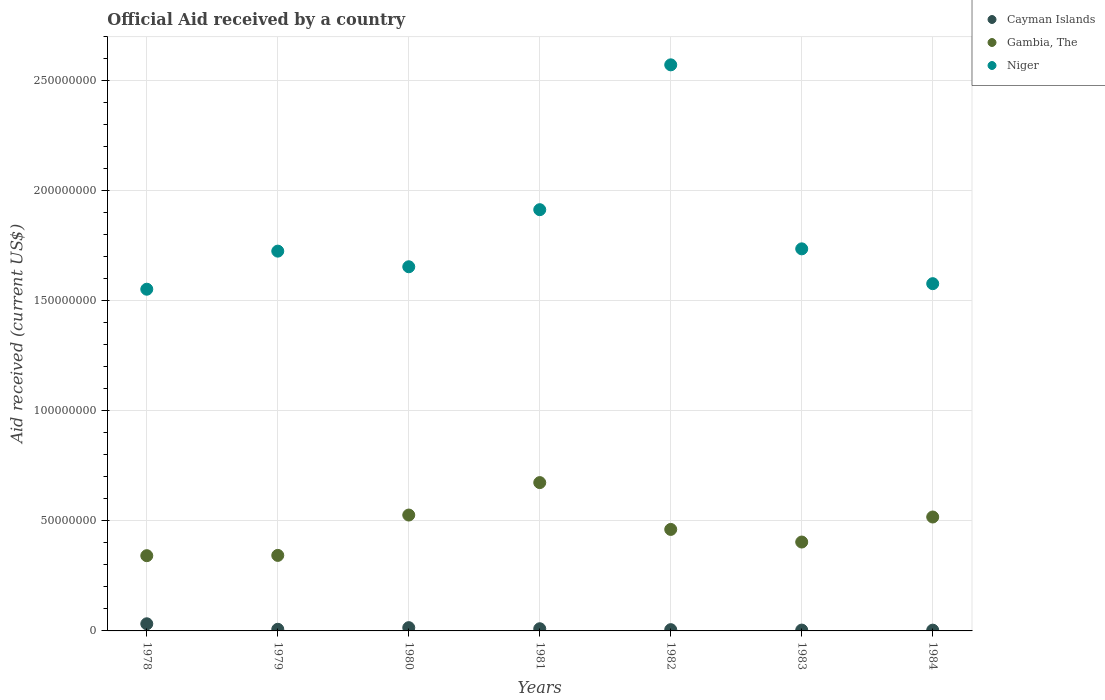How many different coloured dotlines are there?
Your answer should be very brief. 3. What is the net official aid received in Gambia, The in 1983?
Your response must be concise. 4.04e+07. Across all years, what is the maximum net official aid received in Cayman Islands?
Ensure brevity in your answer.  3.24e+06. In which year was the net official aid received in Niger maximum?
Your answer should be very brief. 1982. What is the total net official aid received in Niger in the graph?
Offer a terse response. 1.27e+09. What is the difference between the net official aid received in Niger in 1980 and that in 1981?
Provide a short and direct response. -2.59e+07. What is the difference between the net official aid received in Cayman Islands in 1984 and the net official aid received in Gambia, The in 1982?
Your answer should be compact. -4.58e+07. What is the average net official aid received in Cayman Islands per year?
Give a very brief answer. 1.11e+06. In the year 1978, what is the difference between the net official aid received in Niger and net official aid received in Cayman Islands?
Provide a succinct answer. 1.52e+08. In how many years, is the net official aid received in Gambia, The greater than 220000000 US$?
Offer a very short reply. 0. What is the ratio of the net official aid received in Cayman Islands in 1979 to that in 1982?
Offer a terse response. 1.3. Is the net official aid received in Gambia, The in 1979 less than that in 1980?
Your answer should be compact. Yes. Is the difference between the net official aid received in Niger in 1983 and 1984 greater than the difference between the net official aid received in Cayman Islands in 1983 and 1984?
Your answer should be very brief. Yes. What is the difference between the highest and the second highest net official aid received in Cayman Islands?
Provide a succinct answer. 1.75e+06. What is the difference between the highest and the lowest net official aid received in Niger?
Your answer should be very brief. 1.02e+08. In how many years, is the net official aid received in Niger greater than the average net official aid received in Niger taken over all years?
Offer a terse response. 2. Is the sum of the net official aid received in Gambia, The in 1979 and 1984 greater than the maximum net official aid received in Niger across all years?
Provide a succinct answer. No. Does the net official aid received in Niger monotonically increase over the years?
Ensure brevity in your answer.  No. Is the net official aid received in Niger strictly greater than the net official aid received in Cayman Islands over the years?
Ensure brevity in your answer.  Yes. What is the difference between two consecutive major ticks on the Y-axis?
Offer a terse response. 5.00e+07. Are the values on the major ticks of Y-axis written in scientific E-notation?
Keep it short and to the point. No. Where does the legend appear in the graph?
Offer a very short reply. Top right. What is the title of the graph?
Keep it short and to the point. Official Aid received by a country. Does "Cuba" appear as one of the legend labels in the graph?
Offer a terse response. No. What is the label or title of the X-axis?
Ensure brevity in your answer.  Years. What is the label or title of the Y-axis?
Provide a short and direct response. Aid received (current US$). What is the Aid received (current US$) in Cayman Islands in 1978?
Your response must be concise. 3.24e+06. What is the Aid received (current US$) of Gambia, The in 1978?
Provide a succinct answer. 3.42e+07. What is the Aid received (current US$) in Niger in 1978?
Make the answer very short. 1.55e+08. What is the Aid received (current US$) of Cayman Islands in 1979?
Your answer should be very brief. 7.40e+05. What is the Aid received (current US$) of Gambia, The in 1979?
Provide a succinct answer. 3.43e+07. What is the Aid received (current US$) in Niger in 1979?
Ensure brevity in your answer.  1.73e+08. What is the Aid received (current US$) of Cayman Islands in 1980?
Ensure brevity in your answer.  1.49e+06. What is the Aid received (current US$) in Gambia, The in 1980?
Ensure brevity in your answer.  5.26e+07. What is the Aid received (current US$) of Niger in 1980?
Offer a terse response. 1.65e+08. What is the Aid received (current US$) in Cayman Islands in 1981?
Your answer should be compact. 9.90e+05. What is the Aid received (current US$) of Gambia, The in 1981?
Give a very brief answer. 6.74e+07. What is the Aid received (current US$) in Niger in 1981?
Ensure brevity in your answer.  1.91e+08. What is the Aid received (current US$) in Cayman Islands in 1982?
Offer a very short reply. 5.70e+05. What is the Aid received (current US$) in Gambia, The in 1982?
Make the answer very short. 4.61e+07. What is the Aid received (current US$) in Niger in 1982?
Offer a terse response. 2.57e+08. What is the Aid received (current US$) in Cayman Islands in 1983?
Your response must be concise. 3.80e+05. What is the Aid received (current US$) in Gambia, The in 1983?
Keep it short and to the point. 4.04e+07. What is the Aid received (current US$) in Niger in 1983?
Keep it short and to the point. 1.74e+08. What is the Aid received (current US$) of Gambia, The in 1984?
Your answer should be compact. 5.18e+07. What is the Aid received (current US$) in Niger in 1984?
Your answer should be compact. 1.58e+08. Across all years, what is the maximum Aid received (current US$) of Cayman Islands?
Your answer should be compact. 3.24e+06. Across all years, what is the maximum Aid received (current US$) of Gambia, The?
Your answer should be very brief. 6.74e+07. Across all years, what is the maximum Aid received (current US$) in Niger?
Provide a succinct answer. 2.57e+08. Across all years, what is the minimum Aid received (current US$) in Gambia, The?
Offer a terse response. 3.42e+07. Across all years, what is the minimum Aid received (current US$) of Niger?
Provide a succinct answer. 1.55e+08. What is the total Aid received (current US$) of Cayman Islands in the graph?
Ensure brevity in your answer.  7.76e+06. What is the total Aid received (current US$) in Gambia, The in the graph?
Provide a short and direct response. 3.27e+08. What is the total Aid received (current US$) in Niger in the graph?
Your response must be concise. 1.27e+09. What is the difference between the Aid received (current US$) of Cayman Islands in 1978 and that in 1979?
Provide a succinct answer. 2.50e+06. What is the difference between the Aid received (current US$) in Gambia, The in 1978 and that in 1979?
Make the answer very short. -1.30e+05. What is the difference between the Aid received (current US$) in Niger in 1978 and that in 1979?
Keep it short and to the point. -1.73e+07. What is the difference between the Aid received (current US$) of Cayman Islands in 1978 and that in 1980?
Ensure brevity in your answer.  1.75e+06. What is the difference between the Aid received (current US$) in Gambia, The in 1978 and that in 1980?
Your response must be concise. -1.85e+07. What is the difference between the Aid received (current US$) in Niger in 1978 and that in 1980?
Offer a very short reply. -1.02e+07. What is the difference between the Aid received (current US$) of Cayman Islands in 1978 and that in 1981?
Offer a terse response. 2.25e+06. What is the difference between the Aid received (current US$) in Gambia, The in 1978 and that in 1981?
Offer a terse response. -3.32e+07. What is the difference between the Aid received (current US$) of Niger in 1978 and that in 1981?
Provide a short and direct response. -3.61e+07. What is the difference between the Aid received (current US$) of Cayman Islands in 1978 and that in 1982?
Your response must be concise. 2.67e+06. What is the difference between the Aid received (current US$) of Gambia, The in 1978 and that in 1982?
Provide a succinct answer. -1.19e+07. What is the difference between the Aid received (current US$) of Niger in 1978 and that in 1982?
Provide a succinct answer. -1.02e+08. What is the difference between the Aid received (current US$) in Cayman Islands in 1978 and that in 1983?
Your response must be concise. 2.86e+06. What is the difference between the Aid received (current US$) of Gambia, The in 1978 and that in 1983?
Provide a short and direct response. -6.20e+06. What is the difference between the Aid received (current US$) in Niger in 1978 and that in 1983?
Keep it short and to the point. -1.83e+07. What is the difference between the Aid received (current US$) in Cayman Islands in 1978 and that in 1984?
Offer a terse response. 2.89e+06. What is the difference between the Aid received (current US$) in Gambia, The in 1978 and that in 1984?
Your response must be concise. -1.76e+07. What is the difference between the Aid received (current US$) of Niger in 1978 and that in 1984?
Your response must be concise. -2.52e+06. What is the difference between the Aid received (current US$) in Cayman Islands in 1979 and that in 1980?
Offer a terse response. -7.50e+05. What is the difference between the Aid received (current US$) in Gambia, The in 1979 and that in 1980?
Keep it short and to the point. -1.83e+07. What is the difference between the Aid received (current US$) of Niger in 1979 and that in 1980?
Give a very brief answer. 7.10e+06. What is the difference between the Aid received (current US$) of Cayman Islands in 1979 and that in 1981?
Offer a terse response. -2.50e+05. What is the difference between the Aid received (current US$) of Gambia, The in 1979 and that in 1981?
Your response must be concise. -3.31e+07. What is the difference between the Aid received (current US$) of Niger in 1979 and that in 1981?
Your answer should be compact. -1.88e+07. What is the difference between the Aid received (current US$) of Gambia, The in 1979 and that in 1982?
Give a very brief answer. -1.18e+07. What is the difference between the Aid received (current US$) in Niger in 1979 and that in 1982?
Make the answer very short. -8.46e+07. What is the difference between the Aid received (current US$) in Cayman Islands in 1979 and that in 1983?
Provide a short and direct response. 3.60e+05. What is the difference between the Aid received (current US$) of Gambia, The in 1979 and that in 1983?
Provide a succinct answer. -6.07e+06. What is the difference between the Aid received (current US$) of Niger in 1979 and that in 1983?
Offer a terse response. -1.04e+06. What is the difference between the Aid received (current US$) in Cayman Islands in 1979 and that in 1984?
Give a very brief answer. 3.90e+05. What is the difference between the Aid received (current US$) in Gambia, The in 1979 and that in 1984?
Your response must be concise. -1.74e+07. What is the difference between the Aid received (current US$) of Niger in 1979 and that in 1984?
Ensure brevity in your answer.  1.48e+07. What is the difference between the Aid received (current US$) of Cayman Islands in 1980 and that in 1981?
Provide a succinct answer. 5.00e+05. What is the difference between the Aid received (current US$) in Gambia, The in 1980 and that in 1981?
Ensure brevity in your answer.  -1.47e+07. What is the difference between the Aid received (current US$) in Niger in 1980 and that in 1981?
Offer a very short reply. -2.59e+07. What is the difference between the Aid received (current US$) in Cayman Islands in 1980 and that in 1982?
Offer a terse response. 9.20e+05. What is the difference between the Aid received (current US$) of Gambia, The in 1980 and that in 1982?
Ensure brevity in your answer.  6.53e+06. What is the difference between the Aid received (current US$) in Niger in 1980 and that in 1982?
Provide a succinct answer. -9.17e+07. What is the difference between the Aid received (current US$) of Cayman Islands in 1980 and that in 1983?
Your answer should be very brief. 1.11e+06. What is the difference between the Aid received (current US$) in Gambia, The in 1980 and that in 1983?
Your response must be concise. 1.23e+07. What is the difference between the Aid received (current US$) of Niger in 1980 and that in 1983?
Your response must be concise. -8.14e+06. What is the difference between the Aid received (current US$) in Cayman Islands in 1980 and that in 1984?
Offer a terse response. 1.14e+06. What is the difference between the Aid received (current US$) in Gambia, The in 1980 and that in 1984?
Your response must be concise. 8.90e+05. What is the difference between the Aid received (current US$) of Niger in 1980 and that in 1984?
Your answer should be compact. 7.68e+06. What is the difference between the Aid received (current US$) of Cayman Islands in 1981 and that in 1982?
Provide a short and direct response. 4.20e+05. What is the difference between the Aid received (current US$) in Gambia, The in 1981 and that in 1982?
Ensure brevity in your answer.  2.13e+07. What is the difference between the Aid received (current US$) of Niger in 1981 and that in 1982?
Your answer should be very brief. -6.58e+07. What is the difference between the Aid received (current US$) in Cayman Islands in 1981 and that in 1983?
Offer a very short reply. 6.10e+05. What is the difference between the Aid received (current US$) in Gambia, The in 1981 and that in 1983?
Offer a terse response. 2.70e+07. What is the difference between the Aid received (current US$) of Niger in 1981 and that in 1983?
Make the answer very short. 1.78e+07. What is the difference between the Aid received (current US$) of Cayman Islands in 1981 and that in 1984?
Offer a very short reply. 6.40e+05. What is the difference between the Aid received (current US$) in Gambia, The in 1981 and that in 1984?
Your response must be concise. 1.56e+07. What is the difference between the Aid received (current US$) in Niger in 1981 and that in 1984?
Your answer should be very brief. 3.36e+07. What is the difference between the Aid received (current US$) in Cayman Islands in 1982 and that in 1983?
Provide a short and direct response. 1.90e+05. What is the difference between the Aid received (current US$) in Gambia, The in 1982 and that in 1983?
Offer a very short reply. 5.73e+06. What is the difference between the Aid received (current US$) of Niger in 1982 and that in 1983?
Offer a very short reply. 8.36e+07. What is the difference between the Aid received (current US$) of Gambia, The in 1982 and that in 1984?
Provide a succinct answer. -5.64e+06. What is the difference between the Aid received (current US$) in Niger in 1982 and that in 1984?
Give a very brief answer. 9.94e+07. What is the difference between the Aid received (current US$) of Cayman Islands in 1983 and that in 1984?
Keep it short and to the point. 3.00e+04. What is the difference between the Aid received (current US$) of Gambia, The in 1983 and that in 1984?
Provide a short and direct response. -1.14e+07. What is the difference between the Aid received (current US$) of Niger in 1983 and that in 1984?
Provide a succinct answer. 1.58e+07. What is the difference between the Aid received (current US$) of Cayman Islands in 1978 and the Aid received (current US$) of Gambia, The in 1979?
Give a very brief answer. -3.11e+07. What is the difference between the Aid received (current US$) in Cayman Islands in 1978 and the Aid received (current US$) in Niger in 1979?
Ensure brevity in your answer.  -1.69e+08. What is the difference between the Aid received (current US$) of Gambia, The in 1978 and the Aid received (current US$) of Niger in 1979?
Offer a very short reply. -1.38e+08. What is the difference between the Aid received (current US$) in Cayman Islands in 1978 and the Aid received (current US$) in Gambia, The in 1980?
Ensure brevity in your answer.  -4.94e+07. What is the difference between the Aid received (current US$) in Cayman Islands in 1978 and the Aid received (current US$) in Niger in 1980?
Ensure brevity in your answer.  -1.62e+08. What is the difference between the Aid received (current US$) in Gambia, The in 1978 and the Aid received (current US$) in Niger in 1980?
Offer a terse response. -1.31e+08. What is the difference between the Aid received (current US$) of Cayman Islands in 1978 and the Aid received (current US$) of Gambia, The in 1981?
Make the answer very short. -6.41e+07. What is the difference between the Aid received (current US$) of Cayman Islands in 1978 and the Aid received (current US$) of Niger in 1981?
Ensure brevity in your answer.  -1.88e+08. What is the difference between the Aid received (current US$) of Gambia, The in 1978 and the Aid received (current US$) of Niger in 1981?
Keep it short and to the point. -1.57e+08. What is the difference between the Aid received (current US$) of Cayman Islands in 1978 and the Aid received (current US$) of Gambia, The in 1982?
Your response must be concise. -4.29e+07. What is the difference between the Aid received (current US$) of Cayman Islands in 1978 and the Aid received (current US$) of Niger in 1982?
Give a very brief answer. -2.54e+08. What is the difference between the Aid received (current US$) in Gambia, The in 1978 and the Aid received (current US$) in Niger in 1982?
Your response must be concise. -2.23e+08. What is the difference between the Aid received (current US$) of Cayman Islands in 1978 and the Aid received (current US$) of Gambia, The in 1983?
Your answer should be compact. -3.71e+07. What is the difference between the Aid received (current US$) of Cayman Islands in 1978 and the Aid received (current US$) of Niger in 1983?
Make the answer very short. -1.70e+08. What is the difference between the Aid received (current US$) in Gambia, The in 1978 and the Aid received (current US$) in Niger in 1983?
Provide a succinct answer. -1.39e+08. What is the difference between the Aid received (current US$) in Cayman Islands in 1978 and the Aid received (current US$) in Gambia, The in 1984?
Your answer should be compact. -4.85e+07. What is the difference between the Aid received (current US$) of Cayman Islands in 1978 and the Aid received (current US$) of Niger in 1984?
Offer a very short reply. -1.55e+08. What is the difference between the Aid received (current US$) of Gambia, The in 1978 and the Aid received (current US$) of Niger in 1984?
Make the answer very short. -1.24e+08. What is the difference between the Aid received (current US$) in Cayman Islands in 1979 and the Aid received (current US$) in Gambia, The in 1980?
Keep it short and to the point. -5.19e+07. What is the difference between the Aid received (current US$) in Cayman Islands in 1979 and the Aid received (current US$) in Niger in 1980?
Make the answer very short. -1.65e+08. What is the difference between the Aid received (current US$) in Gambia, The in 1979 and the Aid received (current US$) in Niger in 1980?
Your response must be concise. -1.31e+08. What is the difference between the Aid received (current US$) of Cayman Islands in 1979 and the Aid received (current US$) of Gambia, The in 1981?
Offer a very short reply. -6.66e+07. What is the difference between the Aid received (current US$) of Cayman Islands in 1979 and the Aid received (current US$) of Niger in 1981?
Keep it short and to the point. -1.91e+08. What is the difference between the Aid received (current US$) of Gambia, The in 1979 and the Aid received (current US$) of Niger in 1981?
Your response must be concise. -1.57e+08. What is the difference between the Aid received (current US$) of Cayman Islands in 1979 and the Aid received (current US$) of Gambia, The in 1982?
Offer a very short reply. -4.54e+07. What is the difference between the Aid received (current US$) of Cayman Islands in 1979 and the Aid received (current US$) of Niger in 1982?
Provide a short and direct response. -2.56e+08. What is the difference between the Aid received (current US$) of Gambia, The in 1979 and the Aid received (current US$) of Niger in 1982?
Your answer should be compact. -2.23e+08. What is the difference between the Aid received (current US$) in Cayman Islands in 1979 and the Aid received (current US$) in Gambia, The in 1983?
Your response must be concise. -3.96e+07. What is the difference between the Aid received (current US$) of Cayman Islands in 1979 and the Aid received (current US$) of Niger in 1983?
Give a very brief answer. -1.73e+08. What is the difference between the Aid received (current US$) of Gambia, The in 1979 and the Aid received (current US$) of Niger in 1983?
Keep it short and to the point. -1.39e+08. What is the difference between the Aid received (current US$) of Cayman Islands in 1979 and the Aid received (current US$) of Gambia, The in 1984?
Offer a terse response. -5.10e+07. What is the difference between the Aid received (current US$) in Cayman Islands in 1979 and the Aid received (current US$) in Niger in 1984?
Give a very brief answer. -1.57e+08. What is the difference between the Aid received (current US$) of Gambia, The in 1979 and the Aid received (current US$) of Niger in 1984?
Make the answer very short. -1.23e+08. What is the difference between the Aid received (current US$) of Cayman Islands in 1980 and the Aid received (current US$) of Gambia, The in 1981?
Offer a terse response. -6.59e+07. What is the difference between the Aid received (current US$) of Cayman Islands in 1980 and the Aid received (current US$) of Niger in 1981?
Your answer should be compact. -1.90e+08. What is the difference between the Aid received (current US$) of Gambia, The in 1980 and the Aid received (current US$) of Niger in 1981?
Keep it short and to the point. -1.39e+08. What is the difference between the Aid received (current US$) in Cayman Islands in 1980 and the Aid received (current US$) in Gambia, The in 1982?
Your answer should be very brief. -4.46e+07. What is the difference between the Aid received (current US$) in Cayman Islands in 1980 and the Aid received (current US$) in Niger in 1982?
Make the answer very short. -2.56e+08. What is the difference between the Aid received (current US$) of Gambia, The in 1980 and the Aid received (current US$) of Niger in 1982?
Give a very brief answer. -2.05e+08. What is the difference between the Aid received (current US$) in Cayman Islands in 1980 and the Aid received (current US$) in Gambia, The in 1983?
Your answer should be compact. -3.89e+07. What is the difference between the Aid received (current US$) in Cayman Islands in 1980 and the Aid received (current US$) in Niger in 1983?
Provide a succinct answer. -1.72e+08. What is the difference between the Aid received (current US$) of Gambia, The in 1980 and the Aid received (current US$) of Niger in 1983?
Ensure brevity in your answer.  -1.21e+08. What is the difference between the Aid received (current US$) of Cayman Islands in 1980 and the Aid received (current US$) of Gambia, The in 1984?
Make the answer very short. -5.03e+07. What is the difference between the Aid received (current US$) of Cayman Islands in 1980 and the Aid received (current US$) of Niger in 1984?
Your response must be concise. -1.56e+08. What is the difference between the Aid received (current US$) of Gambia, The in 1980 and the Aid received (current US$) of Niger in 1984?
Your response must be concise. -1.05e+08. What is the difference between the Aid received (current US$) in Cayman Islands in 1981 and the Aid received (current US$) in Gambia, The in 1982?
Offer a very short reply. -4.51e+07. What is the difference between the Aid received (current US$) in Cayman Islands in 1981 and the Aid received (current US$) in Niger in 1982?
Your answer should be compact. -2.56e+08. What is the difference between the Aid received (current US$) in Gambia, The in 1981 and the Aid received (current US$) in Niger in 1982?
Give a very brief answer. -1.90e+08. What is the difference between the Aid received (current US$) in Cayman Islands in 1981 and the Aid received (current US$) in Gambia, The in 1983?
Your answer should be very brief. -3.94e+07. What is the difference between the Aid received (current US$) in Cayman Islands in 1981 and the Aid received (current US$) in Niger in 1983?
Make the answer very short. -1.73e+08. What is the difference between the Aid received (current US$) in Gambia, The in 1981 and the Aid received (current US$) in Niger in 1983?
Offer a terse response. -1.06e+08. What is the difference between the Aid received (current US$) in Cayman Islands in 1981 and the Aid received (current US$) in Gambia, The in 1984?
Offer a terse response. -5.08e+07. What is the difference between the Aid received (current US$) of Cayman Islands in 1981 and the Aid received (current US$) of Niger in 1984?
Your answer should be compact. -1.57e+08. What is the difference between the Aid received (current US$) of Gambia, The in 1981 and the Aid received (current US$) of Niger in 1984?
Your response must be concise. -9.04e+07. What is the difference between the Aid received (current US$) in Cayman Islands in 1982 and the Aid received (current US$) in Gambia, The in 1983?
Give a very brief answer. -3.98e+07. What is the difference between the Aid received (current US$) in Cayman Islands in 1982 and the Aid received (current US$) in Niger in 1983?
Your answer should be very brief. -1.73e+08. What is the difference between the Aid received (current US$) of Gambia, The in 1982 and the Aid received (current US$) of Niger in 1983?
Offer a terse response. -1.27e+08. What is the difference between the Aid received (current US$) of Cayman Islands in 1982 and the Aid received (current US$) of Gambia, The in 1984?
Provide a short and direct response. -5.12e+07. What is the difference between the Aid received (current US$) in Cayman Islands in 1982 and the Aid received (current US$) in Niger in 1984?
Your answer should be very brief. -1.57e+08. What is the difference between the Aid received (current US$) of Gambia, The in 1982 and the Aid received (current US$) of Niger in 1984?
Provide a short and direct response. -1.12e+08. What is the difference between the Aid received (current US$) in Cayman Islands in 1983 and the Aid received (current US$) in Gambia, The in 1984?
Provide a succinct answer. -5.14e+07. What is the difference between the Aid received (current US$) of Cayman Islands in 1983 and the Aid received (current US$) of Niger in 1984?
Offer a terse response. -1.57e+08. What is the difference between the Aid received (current US$) of Gambia, The in 1983 and the Aid received (current US$) of Niger in 1984?
Offer a very short reply. -1.17e+08. What is the average Aid received (current US$) in Cayman Islands per year?
Make the answer very short. 1.11e+06. What is the average Aid received (current US$) of Gambia, The per year?
Your answer should be very brief. 4.67e+07. What is the average Aid received (current US$) in Niger per year?
Keep it short and to the point. 1.82e+08. In the year 1978, what is the difference between the Aid received (current US$) of Cayman Islands and Aid received (current US$) of Gambia, The?
Your answer should be very brief. -3.09e+07. In the year 1978, what is the difference between the Aid received (current US$) of Cayman Islands and Aid received (current US$) of Niger?
Your answer should be compact. -1.52e+08. In the year 1978, what is the difference between the Aid received (current US$) of Gambia, The and Aid received (current US$) of Niger?
Give a very brief answer. -1.21e+08. In the year 1979, what is the difference between the Aid received (current US$) of Cayman Islands and Aid received (current US$) of Gambia, The?
Your answer should be very brief. -3.36e+07. In the year 1979, what is the difference between the Aid received (current US$) of Cayman Islands and Aid received (current US$) of Niger?
Provide a short and direct response. -1.72e+08. In the year 1979, what is the difference between the Aid received (current US$) of Gambia, The and Aid received (current US$) of Niger?
Your answer should be very brief. -1.38e+08. In the year 1980, what is the difference between the Aid received (current US$) of Cayman Islands and Aid received (current US$) of Gambia, The?
Offer a very short reply. -5.12e+07. In the year 1980, what is the difference between the Aid received (current US$) in Cayman Islands and Aid received (current US$) in Niger?
Your response must be concise. -1.64e+08. In the year 1980, what is the difference between the Aid received (current US$) of Gambia, The and Aid received (current US$) of Niger?
Make the answer very short. -1.13e+08. In the year 1981, what is the difference between the Aid received (current US$) in Cayman Islands and Aid received (current US$) in Gambia, The?
Offer a very short reply. -6.64e+07. In the year 1981, what is the difference between the Aid received (current US$) in Cayman Islands and Aid received (current US$) in Niger?
Ensure brevity in your answer.  -1.90e+08. In the year 1981, what is the difference between the Aid received (current US$) in Gambia, The and Aid received (current US$) in Niger?
Offer a terse response. -1.24e+08. In the year 1982, what is the difference between the Aid received (current US$) of Cayman Islands and Aid received (current US$) of Gambia, The?
Offer a very short reply. -4.55e+07. In the year 1982, what is the difference between the Aid received (current US$) in Cayman Islands and Aid received (current US$) in Niger?
Your answer should be compact. -2.57e+08. In the year 1982, what is the difference between the Aid received (current US$) of Gambia, The and Aid received (current US$) of Niger?
Offer a terse response. -2.11e+08. In the year 1983, what is the difference between the Aid received (current US$) in Cayman Islands and Aid received (current US$) in Gambia, The?
Your answer should be compact. -4.00e+07. In the year 1983, what is the difference between the Aid received (current US$) of Cayman Islands and Aid received (current US$) of Niger?
Provide a short and direct response. -1.73e+08. In the year 1983, what is the difference between the Aid received (current US$) of Gambia, The and Aid received (current US$) of Niger?
Provide a short and direct response. -1.33e+08. In the year 1984, what is the difference between the Aid received (current US$) of Cayman Islands and Aid received (current US$) of Gambia, The?
Keep it short and to the point. -5.14e+07. In the year 1984, what is the difference between the Aid received (current US$) in Cayman Islands and Aid received (current US$) in Niger?
Your response must be concise. -1.57e+08. In the year 1984, what is the difference between the Aid received (current US$) in Gambia, The and Aid received (current US$) in Niger?
Offer a terse response. -1.06e+08. What is the ratio of the Aid received (current US$) of Cayman Islands in 1978 to that in 1979?
Give a very brief answer. 4.38. What is the ratio of the Aid received (current US$) of Gambia, The in 1978 to that in 1979?
Your answer should be compact. 1. What is the ratio of the Aid received (current US$) in Niger in 1978 to that in 1979?
Your answer should be very brief. 0.9. What is the ratio of the Aid received (current US$) in Cayman Islands in 1978 to that in 1980?
Your response must be concise. 2.17. What is the ratio of the Aid received (current US$) of Gambia, The in 1978 to that in 1980?
Ensure brevity in your answer.  0.65. What is the ratio of the Aid received (current US$) in Niger in 1978 to that in 1980?
Your response must be concise. 0.94. What is the ratio of the Aid received (current US$) of Cayman Islands in 1978 to that in 1981?
Keep it short and to the point. 3.27. What is the ratio of the Aid received (current US$) in Gambia, The in 1978 to that in 1981?
Make the answer very short. 0.51. What is the ratio of the Aid received (current US$) of Niger in 1978 to that in 1981?
Keep it short and to the point. 0.81. What is the ratio of the Aid received (current US$) in Cayman Islands in 1978 to that in 1982?
Make the answer very short. 5.68. What is the ratio of the Aid received (current US$) of Gambia, The in 1978 to that in 1982?
Your answer should be very brief. 0.74. What is the ratio of the Aid received (current US$) of Niger in 1978 to that in 1982?
Provide a short and direct response. 0.6. What is the ratio of the Aid received (current US$) of Cayman Islands in 1978 to that in 1983?
Offer a very short reply. 8.53. What is the ratio of the Aid received (current US$) of Gambia, The in 1978 to that in 1983?
Make the answer very short. 0.85. What is the ratio of the Aid received (current US$) of Niger in 1978 to that in 1983?
Make the answer very short. 0.89. What is the ratio of the Aid received (current US$) in Cayman Islands in 1978 to that in 1984?
Your answer should be compact. 9.26. What is the ratio of the Aid received (current US$) in Gambia, The in 1978 to that in 1984?
Offer a terse response. 0.66. What is the ratio of the Aid received (current US$) in Niger in 1978 to that in 1984?
Offer a terse response. 0.98. What is the ratio of the Aid received (current US$) of Cayman Islands in 1979 to that in 1980?
Give a very brief answer. 0.5. What is the ratio of the Aid received (current US$) of Gambia, The in 1979 to that in 1980?
Your response must be concise. 0.65. What is the ratio of the Aid received (current US$) in Niger in 1979 to that in 1980?
Provide a short and direct response. 1.04. What is the ratio of the Aid received (current US$) of Cayman Islands in 1979 to that in 1981?
Provide a short and direct response. 0.75. What is the ratio of the Aid received (current US$) in Gambia, The in 1979 to that in 1981?
Provide a short and direct response. 0.51. What is the ratio of the Aid received (current US$) in Niger in 1979 to that in 1981?
Offer a very short reply. 0.9. What is the ratio of the Aid received (current US$) in Cayman Islands in 1979 to that in 1982?
Keep it short and to the point. 1.3. What is the ratio of the Aid received (current US$) of Gambia, The in 1979 to that in 1982?
Keep it short and to the point. 0.74. What is the ratio of the Aid received (current US$) in Niger in 1979 to that in 1982?
Make the answer very short. 0.67. What is the ratio of the Aid received (current US$) in Cayman Islands in 1979 to that in 1983?
Offer a very short reply. 1.95. What is the ratio of the Aid received (current US$) in Gambia, The in 1979 to that in 1983?
Ensure brevity in your answer.  0.85. What is the ratio of the Aid received (current US$) in Cayman Islands in 1979 to that in 1984?
Make the answer very short. 2.11. What is the ratio of the Aid received (current US$) of Gambia, The in 1979 to that in 1984?
Provide a short and direct response. 0.66. What is the ratio of the Aid received (current US$) of Niger in 1979 to that in 1984?
Your answer should be very brief. 1.09. What is the ratio of the Aid received (current US$) in Cayman Islands in 1980 to that in 1981?
Make the answer very short. 1.51. What is the ratio of the Aid received (current US$) of Gambia, The in 1980 to that in 1981?
Offer a very short reply. 0.78. What is the ratio of the Aid received (current US$) in Niger in 1980 to that in 1981?
Your response must be concise. 0.86. What is the ratio of the Aid received (current US$) in Cayman Islands in 1980 to that in 1982?
Provide a succinct answer. 2.61. What is the ratio of the Aid received (current US$) of Gambia, The in 1980 to that in 1982?
Your answer should be very brief. 1.14. What is the ratio of the Aid received (current US$) of Niger in 1980 to that in 1982?
Offer a very short reply. 0.64. What is the ratio of the Aid received (current US$) in Cayman Islands in 1980 to that in 1983?
Your answer should be compact. 3.92. What is the ratio of the Aid received (current US$) in Gambia, The in 1980 to that in 1983?
Ensure brevity in your answer.  1.3. What is the ratio of the Aid received (current US$) of Niger in 1980 to that in 1983?
Keep it short and to the point. 0.95. What is the ratio of the Aid received (current US$) in Cayman Islands in 1980 to that in 1984?
Give a very brief answer. 4.26. What is the ratio of the Aid received (current US$) of Gambia, The in 1980 to that in 1984?
Your answer should be compact. 1.02. What is the ratio of the Aid received (current US$) of Niger in 1980 to that in 1984?
Keep it short and to the point. 1.05. What is the ratio of the Aid received (current US$) of Cayman Islands in 1981 to that in 1982?
Your answer should be very brief. 1.74. What is the ratio of the Aid received (current US$) of Gambia, The in 1981 to that in 1982?
Your answer should be compact. 1.46. What is the ratio of the Aid received (current US$) in Niger in 1981 to that in 1982?
Your response must be concise. 0.74. What is the ratio of the Aid received (current US$) in Cayman Islands in 1981 to that in 1983?
Give a very brief answer. 2.61. What is the ratio of the Aid received (current US$) of Gambia, The in 1981 to that in 1983?
Give a very brief answer. 1.67. What is the ratio of the Aid received (current US$) in Niger in 1981 to that in 1983?
Your answer should be compact. 1.1. What is the ratio of the Aid received (current US$) of Cayman Islands in 1981 to that in 1984?
Your answer should be very brief. 2.83. What is the ratio of the Aid received (current US$) in Gambia, The in 1981 to that in 1984?
Provide a short and direct response. 1.3. What is the ratio of the Aid received (current US$) of Niger in 1981 to that in 1984?
Offer a terse response. 1.21. What is the ratio of the Aid received (current US$) of Cayman Islands in 1982 to that in 1983?
Give a very brief answer. 1.5. What is the ratio of the Aid received (current US$) of Gambia, The in 1982 to that in 1983?
Offer a very short reply. 1.14. What is the ratio of the Aid received (current US$) of Niger in 1982 to that in 1983?
Provide a succinct answer. 1.48. What is the ratio of the Aid received (current US$) of Cayman Islands in 1982 to that in 1984?
Offer a very short reply. 1.63. What is the ratio of the Aid received (current US$) in Gambia, The in 1982 to that in 1984?
Provide a succinct answer. 0.89. What is the ratio of the Aid received (current US$) of Niger in 1982 to that in 1984?
Give a very brief answer. 1.63. What is the ratio of the Aid received (current US$) of Cayman Islands in 1983 to that in 1984?
Keep it short and to the point. 1.09. What is the ratio of the Aid received (current US$) of Gambia, The in 1983 to that in 1984?
Give a very brief answer. 0.78. What is the ratio of the Aid received (current US$) of Niger in 1983 to that in 1984?
Keep it short and to the point. 1.1. What is the difference between the highest and the second highest Aid received (current US$) of Cayman Islands?
Offer a very short reply. 1.75e+06. What is the difference between the highest and the second highest Aid received (current US$) in Gambia, The?
Offer a terse response. 1.47e+07. What is the difference between the highest and the second highest Aid received (current US$) in Niger?
Offer a very short reply. 6.58e+07. What is the difference between the highest and the lowest Aid received (current US$) of Cayman Islands?
Offer a very short reply. 2.89e+06. What is the difference between the highest and the lowest Aid received (current US$) of Gambia, The?
Provide a short and direct response. 3.32e+07. What is the difference between the highest and the lowest Aid received (current US$) of Niger?
Give a very brief answer. 1.02e+08. 